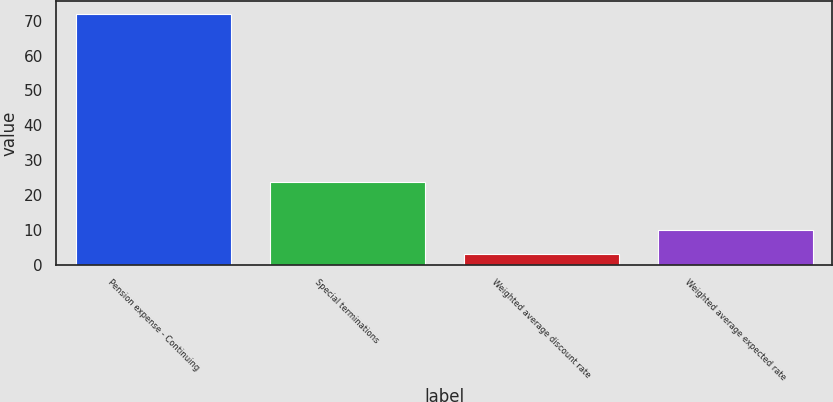Convert chart to OTSL. <chart><loc_0><loc_0><loc_500><loc_500><bar_chart><fcel>Pension expense - Continuing<fcel>Special terminations<fcel>Weighted average discount rate<fcel>Weighted average expected rate<nl><fcel>72<fcel>23.7<fcel>3<fcel>9.9<nl></chart> 